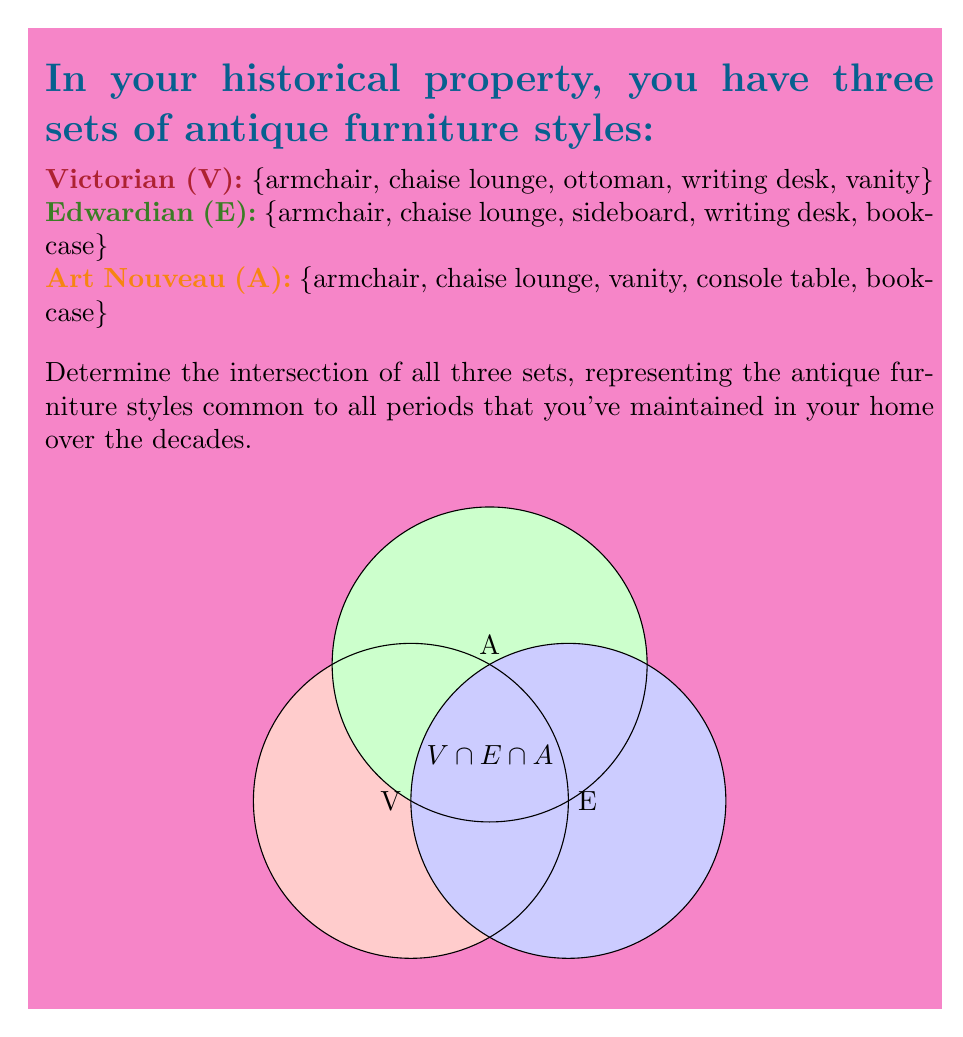Give your solution to this math problem. To find the intersection of these three sets, we need to identify the elements that are present in all three sets. Let's approach this step-by-step:

1) First, let's write out our sets:
   $V = \{armchair, chaise lounge, ottoman, writing desk, vanity\}$
   $E = \{armchair, chaise lounge, sideboard, writing desk, bookcase\}$
   $A = \{armchair, chaise lounge, vanity, console table, bookcase\}$

2) We're looking for $V \cap E \cap A$, which means elements that appear in all three sets.

3) Let's start with V and E:
   $V \cap E = \{armchair, chaise lounge, writing desk\}$

4) Now, let's intersect this result with A:
   $(V \cap E) \cap A = \{armchair, chaise lounge\}$

5) These are the only two elements that appear in all three sets.

Therefore, the intersection of all three sets contains two elements: armchair and chaise lounge. These represent the antique furniture styles that have remained consistent across all three periods in your historical property.
Answer: $V \cap E \cap A = \{armchair, chaise lounge\}$ 